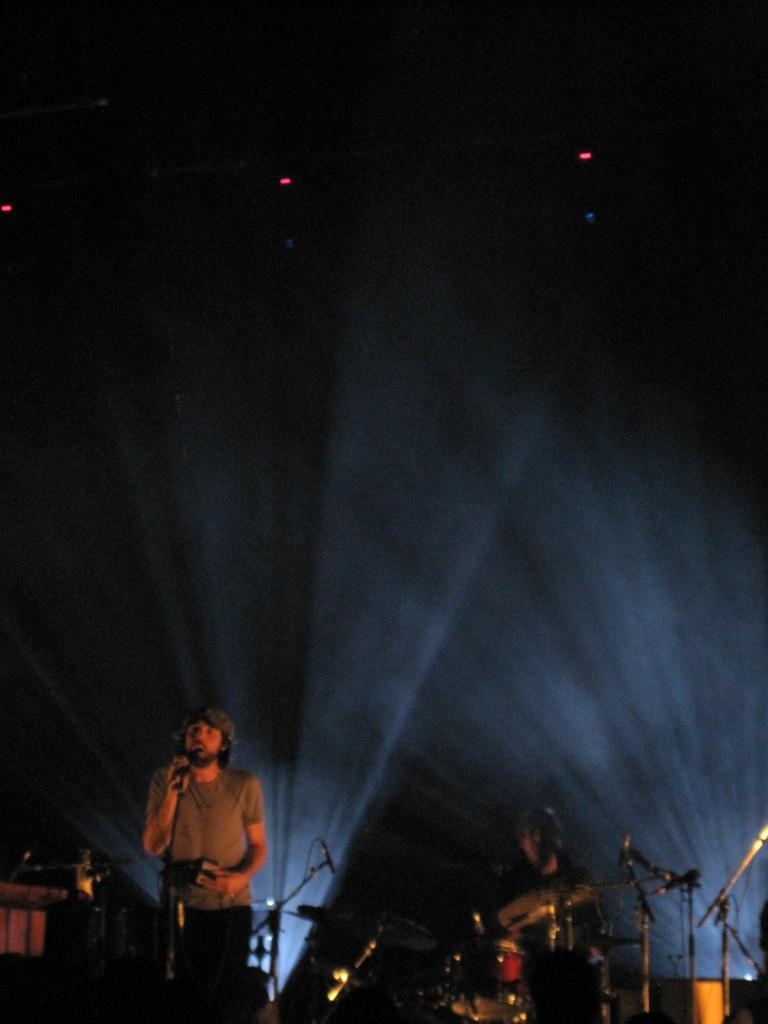What is the man in the image doing? The man is standing in front of a mic. What other objects can be seen at the bottom of the picture? Musical instruments are visible at the bottom of the picture. How would you describe the lighting in the image? The background of the image is dark. Can you see a truck in the image? No, there is no truck present in the image. How many people are playing volleyball in the image? There is no volleyball or people playing volleyball in the image. 